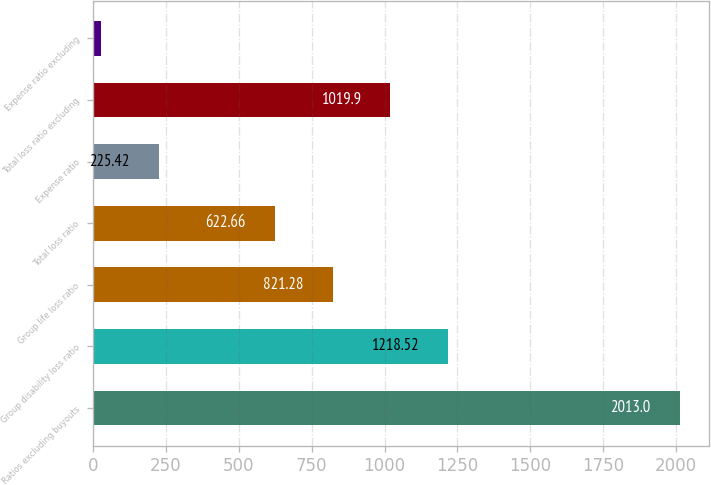<chart> <loc_0><loc_0><loc_500><loc_500><bar_chart><fcel>Ratios excluding buyouts<fcel>Group disability loss ratio<fcel>Group life loss ratio<fcel>Total loss ratio<fcel>Expense ratio<fcel>Total loss ratio excluding<fcel>Expense ratio excluding<nl><fcel>2013<fcel>1218.52<fcel>821.28<fcel>622.66<fcel>225.42<fcel>1019.9<fcel>26.8<nl></chart> 